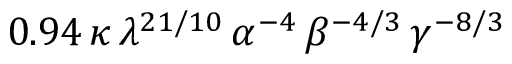<formula> <loc_0><loc_0><loc_500><loc_500>0 . 9 4 \, \kappa \, \lambda ^ { 2 1 / 1 0 } \, \alpha ^ { - 4 } \, \beta ^ { - 4 / 3 } \, \gamma ^ { - 8 / 3 }</formula> 